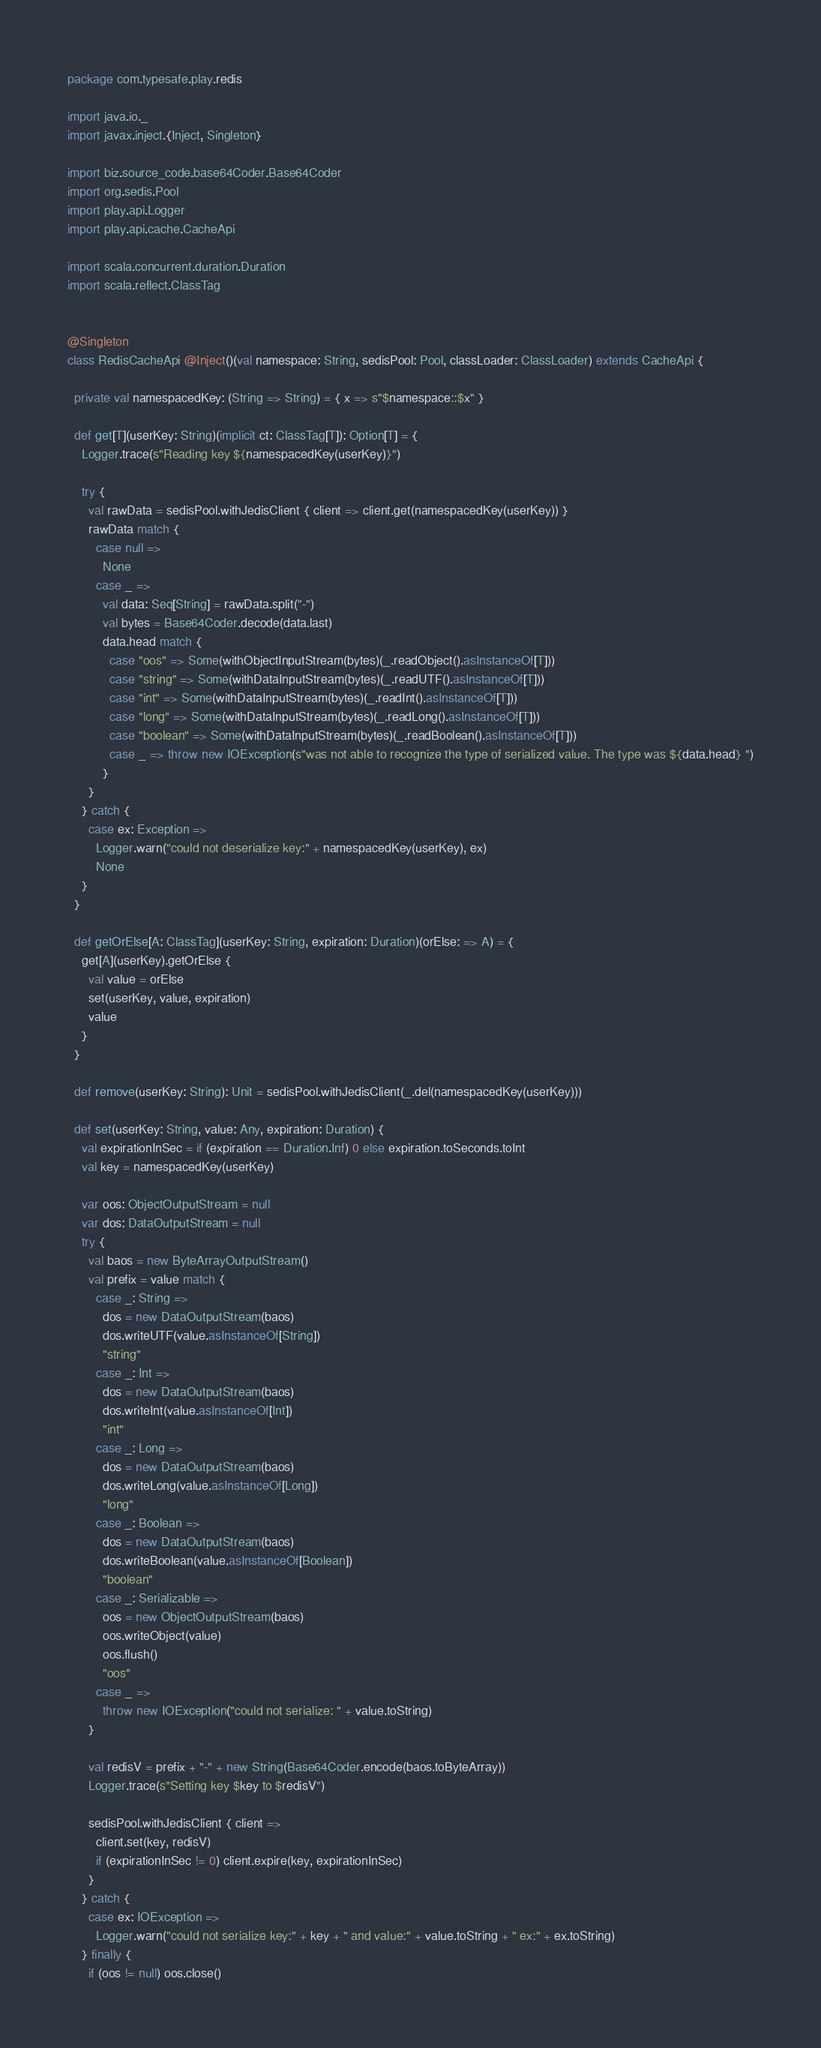<code> <loc_0><loc_0><loc_500><loc_500><_Scala_>package com.typesafe.play.redis

import java.io._
import javax.inject.{Inject, Singleton}

import biz.source_code.base64Coder.Base64Coder
import org.sedis.Pool
import play.api.Logger
import play.api.cache.CacheApi

import scala.concurrent.duration.Duration
import scala.reflect.ClassTag


@Singleton
class RedisCacheApi @Inject()(val namespace: String, sedisPool: Pool, classLoader: ClassLoader) extends CacheApi {

  private val namespacedKey: (String => String) = { x => s"$namespace::$x" }

  def get[T](userKey: String)(implicit ct: ClassTag[T]): Option[T] = {
    Logger.trace(s"Reading key ${namespacedKey(userKey)}")

    try {
      val rawData = sedisPool.withJedisClient { client => client.get(namespacedKey(userKey)) }
      rawData match {
        case null =>
          None
        case _ =>
          val data: Seq[String] = rawData.split("-")
          val bytes = Base64Coder.decode(data.last)
          data.head match {
            case "oos" => Some(withObjectInputStream(bytes)(_.readObject().asInstanceOf[T]))
            case "string" => Some(withDataInputStream(bytes)(_.readUTF().asInstanceOf[T]))
            case "int" => Some(withDataInputStream(bytes)(_.readInt().asInstanceOf[T]))
            case "long" => Some(withDataInputStream(bytes)(_.readLong().asInstanceOf[T]))
            case "boolean" => Some(withDataInputStream(bytes)(_.readBoolean().asInstanceOf[T]))
            case _ => throw new IOException(s"was not able to recognize the type of serialized value. The type was ${data.head} ")
          }
      }
    } catch {
      case ex: Exception =>
        Logger.warn("could not deserialize key:" + namespacedKey(userKey), ex)
        None
    }
  }

  def getOrElse[A: ClassTag](userKey: String, expiration: Duration)(orElse: => A) = {
    get[A](userKey).getOrElse {
      val value = orElse
      set(userKey, value, expiration)
      value
    }
  }

  def remove(userKey: String): Unit = sedisPool.withJedisClient(_.del(namespacedKey(userKey)))

  def set(userKey: String, value: Any, expiration: Duration) {
    val expirationInSec = if (expiration == Duration.Inf) 0 else expiration.toSeconds.toInt
    val key = namespacedKey(userKey)

    var oos: ObjectOutputStream = null
    var dos: DataOutputStream = null
    try {
      val baos = new ByteArrayOutputStream()
      val prefix = value match {
        case _: String =>
          dos = new DataOutputStream(baos)
          dos.writeUTF(value.asInstanceOf[String])
          "string"
        case _: Int =>
          dos = new DataOutputStream(baos)
          dos.writeInt(value.asInstanceOf[Int])
          "int"
        case _: Long =>
          dos = new DataOutputStream(baos)
          dos.writeLong(value.asInstanceOf[Long])
          "long"
        case _: Boolean =>
          dos = new DataOutputStream(baos)
          dos.writeBoolean(value.asInstanceOf[Boolean])
          "boolean"
        case _: Serializable =>
          oos = new ObjectOutputStream(baos)
          oos.writeObject(value)
          oos.flush()
          "oos"
        case _ =>
          throw new IOException("could not serialize: " + value.toString)
      }

      val redisV = prefix + "-" + new String(Base64Coder.encode(baos.toByteArray))
      Logger.trace(s"Setting key $key to $redisV")

      sedisPool.withJedisClient { client =>
        client.set(key, redisV)
        if (expirationInSec != 0) client.expire(key, expirationInSec)
      }
    } catch {
      case ex: IOException =>
        Logger.warn("could not serialize key:" + key + " and value:" + value.toString + " ex:" + ex.toString)
    } finally {
      if (oos != null) oos.close()</code> 